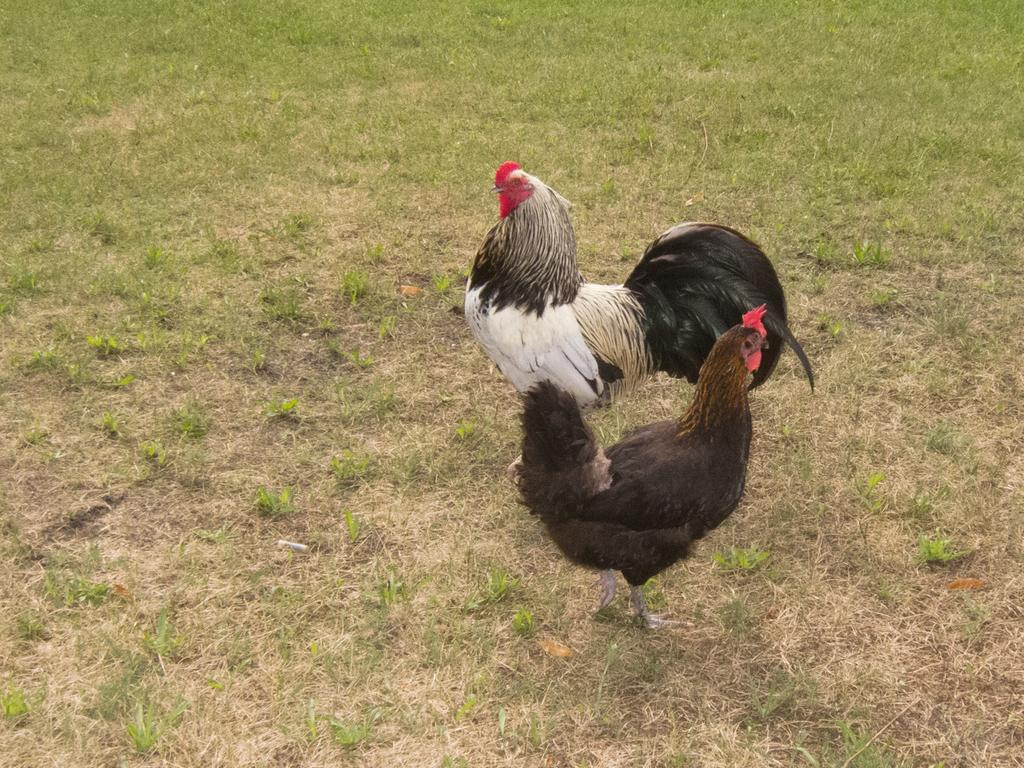What type of animals are in the image? There are two hens in the image. What is the ground made of in the image? The hens are standing on a greenery ground. How does the hen slip on the way in the image? There is no indication in the image that the hen is slipping or tripping; it is standing on a greenery ground. 